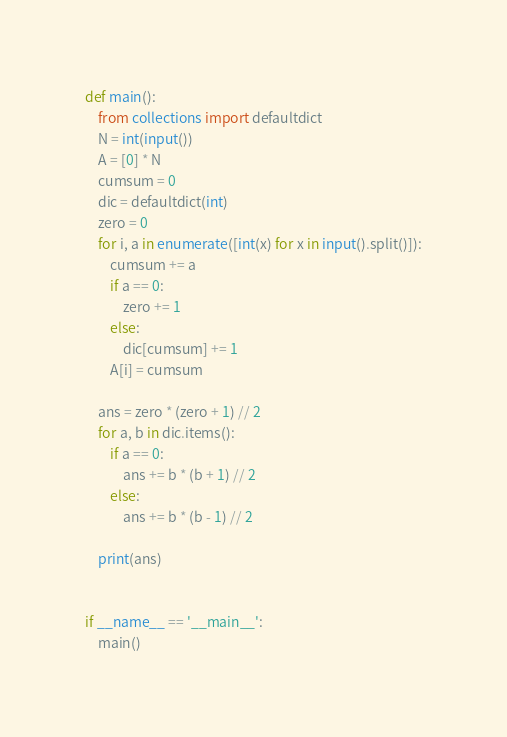<code> <loc_0><loc_0><loc_500><loc_500><_Python_>def main():
    from collections import defaultdict
    N = int(input())
    A = [0] * N
    cumsum = 0
    dic = defaultdict(int)
    zero = 0
    for i, a in enumerate([int(x) for x in input().split()]):
        cumsum += a
        if a == 0:
            zero += 1
        else:
            dic[cumsum] += 1
        A[i] = cumsum

    ans = zero * (zero + 1) // 2
    for a, b in dic.items():
        if a == 0:
            ans += b * (b + 1) // 2
        else:
            ans += b * (b - 1) // 2
    
    print(ans)


if __name__ == '__main__':
    main()</code> 